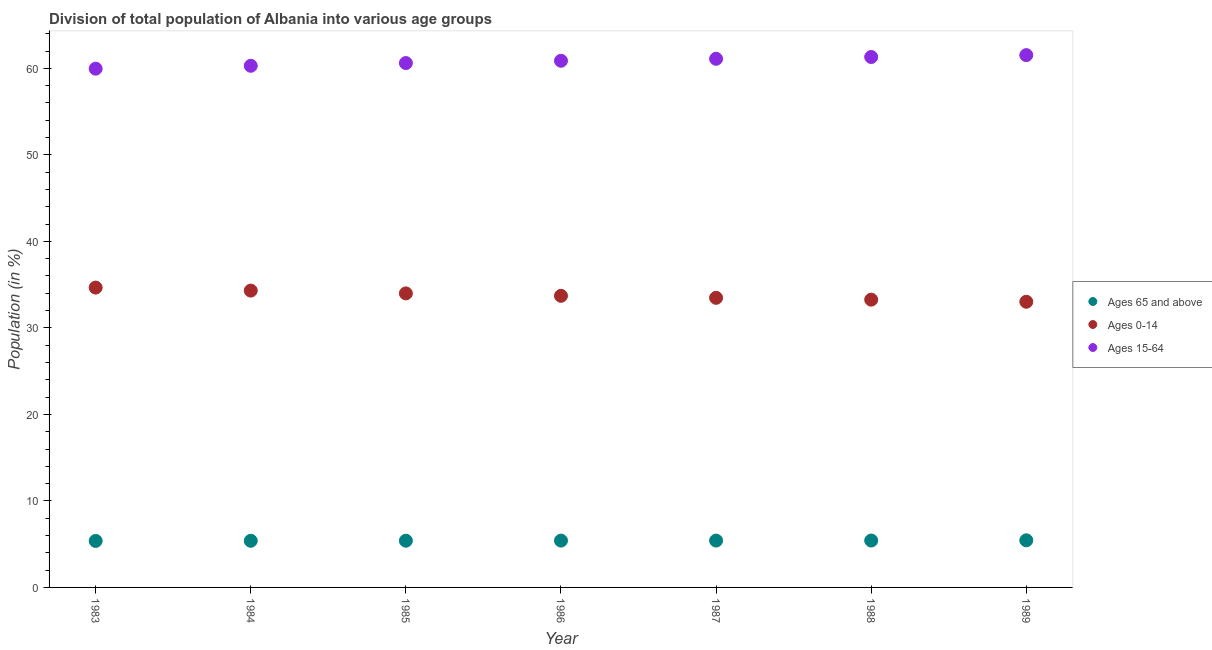How many different coloured dotlines are there?
Your answer should be very brief. 3. Is the number of dotlines equal to the number of legend labels?
Provide a succinct answer. Yes. What is the percentage of population within the age-group 0-14 in 1988?
Keep it short and to the point. 33.26. Across all years, what is the maximum percentage of population within the age-group 15-64?
Give a very brief answer. 61.53. Across all years, what is the minimum percentage of population within the age-group 15-64?
Offer a terse response. 59.96. What is the total percentage of population within the age-group of 65 and above in the graph?
Offer a terse response. 37.86. What is the difference between the percentage of population within the age-group of 65 and above in 1984 and that in 1985?
Your answer should be very brief. -0.01. What is the difference between the percentage of population within the age-group 0-14 in 1986 and the percentage of population within the age-group of 65 and above in 1984?
Give a very brief answer. 28.32. What is the average percentage of population within the age-group 0-14 per year?
Offer a very short reply. 33.78. In the year 1984, what is the difference between the percentage of population within the age-group 0-14 and percentage of population within the age-group of 65 and above?
Provide a succinct answer. 28.92. In how many years, is the percentage of population within the age-group of 65 and above greater than 22 %?
Your answer should be compact. 0. What is the ratio of the percentage of population within the age-group 15-64 in 1983 to that in 1984?
Offer a terse response. 0.99. Is the percentage of population within the age-group 0-14 in 1983 less than that in 1985?
Offer a terse response. No. Is the difference between the percentage of population within the age-group 15-64 in 1984 and 1987 greater than the difference between the percentage of population within the age-group 0-14 in 1984 and 1987?
Provide a short and direct response. No. What is the difference between the highest and the second highest percentage of population within the age-group 15-64?
Ensure brevity in your answer.  0.22. What is the difference between the highest and the lowest percentage of population within the age-group 15-64?
Ensure brevity in your answer.  1.57. In how many years, is the percentage of population within the age-group 0-14 greater than the average percentage of population within the age-group 0-14 taken over all years?
Your response must be concise. 3. Is the sum of the percentage of population within the age-group 15-64 in 1986 and 1988 greater than the maximum percentage of population within the age-group 0-14 across all years?
Your response must be concise. Yes. Is it the case that in every year, the sum of the percentage of population within the age-group of 65 and above and percentage of population within the age-group 0-14 is greater than the percentage of population within the age-group 15-64?
Your answer should be compact. No. Is the percentage of population within the age-group 0-14 strictly greater than the percentage of population within the age-group 15-64 over the years?
Give a very brief answer. No. How many years are there in the graph?
Provide a succinct answer. 7. Are the values on the major ticks of Y-axis written in scientific E-notation?
Your answer should be very brief. No. Where does the legend appear in the graph?
Your response must be concise. Center right. How many legend labels are there?
Offer a terse response. 3. How are the legend labels stacked?
Make the answer very short. Vertical. What is the title of the graph?
Offer a very short reply. Division of total population of Albania into various age groups
. Does "Natural Gas" appear as one of the legend labels in the graph?
Ensure brevity in your answer.  No. What is the label or title of the X-axis?
Keep it short and to the point. Year. What is the label or title of the Y-axis?
Your answer should be compact. Population (in %). What is the Population (in %) in Ages 65 and above in 1983?
Keep it short and to the point. 5.38. What is the Population (in %) of Ages 0-14 in 1983?
Make the answer very short. 34.66. What is the Population (in %) in Ages 15-64 in 1983?
Give a very brief answer. 59.96. What is the Population (in %) in Ages 65 and above in 1984?
Make the answer very short. 5.39. What is the Population (in %) in Ages 0-14 in 1984?
Ensure brevity in your answer.  34.31. What is the Population (in %) in Ages 15-64 in 1984?
Provide a short and direct response. 60.3. What is the Population (in %) of Ages 65 and above in 1985?
Provide a succinct answer. 5.4. What is the Population (in %) in Ages 0-14 in 1985?
Provide a short and direct response. 33.99. What is the Population (in %) of Ages 15-64 in 1985?
Provide a short and direct response. 60.61. What is the Population (in %) in Ages 65 and above in 1986?
Your answer should be compact. 5.41. What is the Population (in %) in Ages 0-14 in 1986?
Provide a short and direct response. 33.71. What is the Population (in %) in Ages 15-64 in 1986?
Your answer should be compact. 60.88. What is the Population (in %) in Ages 65 and above in 1987?
Provide a short and direct response. 5.42. What is the Population (in %) in Ages 0-14 in 1987?
Offer a terse response. 33.48. What is the Population (in %) of Ages 15-64 in 1987?
Keep it short and to the point. 61.11. What is the Population (in %) in Ages 65 and above in 1988?
Provide a short and direct response. 5.42. What is the Population (in %) of Ages 0-14 in 1988?
Keep it short and to the point. 33.26. What is the Population (in %) of Ages 15-64 in 1988?
Your answer should be compact. 61.31. What is the Population (in %) in Ages 65 and above in 1989?
Your answer should be very brief. 5.45. What is the Population (in %) in Ages 0-14 in 1989?
Keep it short and to the point. 33.02. What is the Population (in %) in Ages 15-64 in 1989?
Make the answer very short. 61.53. Across all years, what is the maximum Population (in %) in Ages 65 and above?
Make the answer very short. 5.45. Across all years, what is the maximum Population (in %) in Ages 0-14?
Provide a succinct answer. 34.66. Across all years, what is the maximum Population (in %) of Ages 15-64?
Your answer should be compact. 61.53. Across all years, what is the minimum Population (in %) of Ages 65 and above?
Keep it short and to the point. 5.38. Across all years, what is the minimum Population (in %) in Ages 0-14?
Make the answer very short. 33.02. Across all years, what is the minimum Population (in %) of Ages 15-64?
Provide a succinct answer. 59.96. What is the total Population (in %) of Ages 65 and above in the graph?
Your answer should be very brief. 37.86. What is the total Population (in %) of Ages 0-14 in the graph?
Make the answer very short. 236.43. What is the total Population (in %) of Ages 15-64 in the graph?
Your answer should be very brief. 425.71. What is the difference between the Population (in %) in Ages 65 and above in 1983 and that in 1984?
Offer a very short reply. -0.02. What is the difference between the Population (in %) in Ages 0-14 in 1983 and that in 1984?
Provide a short and direct response. 0.35. What is the difference between the Population (in %) of Ages 15-64 in 1983 and that in 1984?
Offer a terse response. -0.33. What is the difference between the Population (in %) of Ages 65 and above in 1983 and that in 1985?
Provide a succinct answer. -0.02. What is the difference between the Population (in %) of Ages 0-14 in 1983 and that in 1985?
Keep it short and to the point. 0.67. What is the difference between the Population (in %) in Ages 15-64 in 1983 and that in 1985?
Ensure brevity in your answer.  -0.65. What is the difference between the Population (in %) of Ages 65 and above in 1983 and that in 1986?
Your response must be concise. -0.04. What is the difference between the Population (in %) of Ages 0-14 in 1983 and that in 1986?
Provide a succinct answer. 0.95. What is the difference between the Population (in %) in Ages 15-64 in 1983 and that in 1986?
Offer a terse response. -0.91. What is the difference between the Population (in %) in Ages 65 and above in 1983 and that in 1987?
Make the answer very short. -0.04. What is the difference between the Population (in %) in Ages 0-14 in 1983 and that in 1987?
Give a very brief answer. 1.18. What is the difference between the Population (in %) of Ages 15-64 in 1983 and that in 1987?
Ensure brevity in your answer.  -1.14. What is the difference between the Population (in %) of Ages 65 and above in 1983 and that in 1988?
Provide a short and direct response. -0.04. What is the difference between the Population (in %) in Ages 0-14 in 1983 and that in 1988?
Give a very brief answer. 1.39. What is the difference between the Population (in %) of Ages 15-64 in 1983 and that in 1988?
Offer a very short reply. -1.35. What is the difference between the Population (in %) in Ages 65 and above in 1983 and that in 1989?
Your response must be concise. -0.07. What is the difference between the Population (in %) of Ages 0-14 in 1983 and that in 1989?
Make the answer very short. 1.64. What is the difference between the Population (in %) in Ages 15-64 in 1983 and that in 1989?
Give a very brief answer. -1.57. What is the difference between the Population (in %) in Ages 65 and above in 1984 and that in 1985?
Provide a succinct answer. -0.01. What is the difference between the Population (in %) in Ages 0-14 in 1984 and that in 1985?
Your response must be concise. 0.32. What is the difference between the Population (in %) of Ages 15-64 in 1984 and that in 1985?
Offer a terse response. -0.31. What is the difference between the Population (in %) in Ages 65 and above in 1984 and that in 1986?
Offer a terse response. -0.02. What is the difference between the Population (in %) of Ages 0-14 in 1984 and that in 1986?
Offer a terse response. 0.6. What is the difference between the Population (in %) of Ages 15-64 in 1984 and that in 1986?
Make the answer very short. -0.58. What is the difference between the Population (in %) of Ages 65 and above in 1984 and that in 1987?
Offer a very short reply. -0.02. What is the difference between the Population (in %) in Ages 0-14 in 1984 and that in 1987?
Provide a short and direct response. 0.83. What is the difference between the Population (in %) in Ages 15-64 in 1984 and that in 1987?
Ensure brevity in your answer.  -0.81. What is the difference between the Population (in %) in Ages 65 and above in 1984 and that in 1988?
Your answer should be very brief. -0.03. What is the difference between the Population (in %) in Ages 0-14 in 1984 and that in 1988?
Give a very brief answer. 1.05. What is the difference between the Population (in %) in Ages 15-64 in 1984 and that in 1988?
Provide a short and direct response. -1.02. What is the difference between the Population (in %) in Ages 65 and above in 1984 and that in 1989?
Provide a short and direct response. -0.05. What is the difference between the Population (in %) in Ages 0-14 in 1984 and that in 1989?
Provide a succinct answer. 1.29. What is the difference between the Population (in %) of Ages 15-64 in 1984 and that in 1989?
Your answer should be compact. -1.23. What is the difference between the Population (in %) in Ages 65 and above in 1985 and that in 1986?
Keep it short and to the point. -0.01. What is the difference between the Population (in %) in Ages 0-14 in 1985 and that in 1986?
Your answer should be compact. 0.28. What is the difference between the Population (in %) of Ages 15-64 in 1985 and that in 1986?
Your response must be concise. -0.26. What is the difference between the Population (in %) of Ages 65 and above in 1985 and that in 1987?
Make the answer very short. -0.02. What is the difference between the Population (in %) in Ages 0-14 in 1985 and that in 1987?
Your answer should be compact. 0.51. What is the difference between the Population (in %) of Ages 15-64 in 1985 and that in 1987?
Your response must be concise. -0.49. What is the difference between the Population (in %) in Ages 65 and above in 1985 and that in 1988?
Offer a very short reply. -0.02. What is the difference between the Population (in %) in Ages 0-14 in 1985 and that in 1988?
Keep it short and to the point. 0.72. What is the difference between the Population (in %) in Ages 15-64 in 1985 and that in 1988?
Offer a very short reply. -0.7. What is the difference between the Population (in %) in Ages 65 and above in 1985 and that in 1989?
Offer a very short reply. -0.05. What is the difference between the Population (in %) of Ages 0-14 in 1985 and that in 1989?
Keep it short and to the point. 0.97. What is the difference between the Population (in %) in Ages 15-64 in 1985 and that in 1989?
Give a very brief answer. -0.92. What is the difference between the Population (in %) of Ages 65 and above in 1986 and that in 1987?
Offer a terse response. -0. What is the difference between the Population (in %) of Ages 0-14 in 1986 and that in 1987?
Your answer should be compact. 0.23. What is the difference between the Population (in %) of Ages 15-64 in 1986 and that in 1987?
Provide a short and direct response. -0.23. What is the difference between the Population (in %) of Ages 65 and above in 1986 and that in 1988?
Your answer should be very brief. -0.01. What is the difference between the Population (in %) in Ages 0-14 in 1986 and that in 1988?
Make the answer very short. 0.45. What is the difference between the Population (in %) in Ages 15-64 in 1986 and that in 1988?
Keep it short and to the point. -0.44. What is the difference between the Population (in %) of Ages 65 and above in 1986 and that in 1989?
Your answer should be compact. -0.03. What is the difference between the Population (in %) in Ages 0-14 in 1986 and that in 1989?
Offer a very short reply. 0.69. What is the difference between the Population (in %) in Ages 15-64 in 1986 and that in 1989?
Provide a succinct answer. -0.65. What is the difference between the Population (in %) of Ages 65 and above in 1987 and that in 1988?
Make the answer very short. -0. What is the difference between the Population (in %) in Ages 0-14 in 1987 and that in 1988?
Offer a terse response. 0.21. What is the difference between the Population (in %) of Ages 15-64 in 1987 and that in 1988?
Provide a succinct answer. -0.21. What is the difference between the Population (in %) in Ages 65 and above in 1987 and that in 1989?
Give a very brief answer. -0.03. What is the difference between the Population (in %) of Ages 0-14 in 1987 and that in 1989?
Provide a succinct answer. 0.45. What is the difference between the Population (in %) in Ages 15-64 in 1987 and that in 1989?
Give a very brief answer. -0.42. What is the difference between the Population (in %) in Ages 65 and above in 1988 and that in 1989?
Make the answer very short. -0.03. What is the difference between the Population (in %) in Ages 0-14 in 1988 and that in 1989?
Offer a terse response. 0.24. What is the difference between the Population (in %) in Ages 15-64 in 1988 and that in 1989?
Your response must be concise. -0.22. What is the difference between the Population (in %) of Ages 65 and above in 1983 and the Population (in %) of Ages 0-14 in 1984?
Your response must be concise. -28.94. What is the difference between the Population (in %) of Ages 65 and above in 1983 and the Population (in %) of Ages 15-64 in 1984?
Your answer should be very brief. -54.92. What is the difference between the Population (in %) in Ages 0-14 in 1983 and the Population (in %) in Ages 15-64 in 1984?
Provide a succinct answer. -25.64. What is the difference between the Population (in %) of Ages 65 and above in 1983 and the Population (in %) of Ages 0-14 in 1985?
Your response must be concise. -28.61. What is the difference between the Population (in %) in Ages 65 and above in 1983 and the Population (in %) in Ages 15-64 in 1985?
Your answer should be very brief. -55.24. What is the difference between the Population (in %) in Ages 0-14 in 1983 and the Population (in %) in Ages 15-64 in 1985?
Offer a very short reply. -25.95. What is the difference between the Population (in %) in Ages 65 and above in 1983 and the Population (in %) in Ages 0-14 in 1986?
Your response must be concise. -28.33. What is the difference between the Population (in %) of Ages 65 and above in 1983 and the Population (in %) of Ages 15-64 in 1986?
Provide a short and direct response. -55.5. What is the difference between the Population (in %) of Ages 0-14 in 1983 and the Population (in %) of Ages 15-64 in 1986?
Keep it short and to the point. -26.22. What is the difference between the Population (in %) of Ages 65 and above in 1983 and the Population (in %) of Ages 0-14 in 1987?
Keep it short and to the point. -28.1. What is the difference between the Population (in %) in Ages 65 and above in 1983 and the Population (in %) in Ages 15-64 in 1987?
Your answer should be very brief. -55.73. What is the difference between the Population (in %) in Ages 0-14 in 1983 and the Population (in %) in Ages 15-64 in 1987?
Provide a short and direct response. -26.45. What is the difference between the Population (in %) in Ages 65 and above in 1983 and the Population (in %) in Ages 0-14 in 1988?
Your answer should be compact. -27.89. What is the difference between the Population (in %) of Ages 65 and above in 1983 and the Population (in %) of Ages 15-64 in 1988?
Your answer should be compact. -55.94. What is the difference between the Population (in %) in Ages 0-14 in 1983 and the Population (in %) in Ages 15-64 in 1988?
Provide a succinct answer. -26.66. What is the difference between the Population (in %) in Ages 65 and above in 1983 and the Population (in %) in Ages 0-14 in 1989?
Offer a very short reply. -27.65. What is the difference between the Population (in %) in Ages 65 and above in 1983 and the Population (in %) in Ages 15-64 in 1989?
Provide a succinct answer. -56.16. What is the difference between the Population (in %) in Ages 0-14 in 1983 and the Population (in %) in Ages 15-64 in 1989?
Give a very brief answer. -26.87. What is the difference between the Population (in %) of Ages 65 and above in 1984 and the Population (in %) of Ages 0-14 in 1985?
Provide a short and direct response. -28.6. What is the difference between the Population (in %) of Ages 65 and above in 1984 and the Population (in %) of Ages 15-64 in 1985?
Give a very brief answer. -55.22. What is the difference between the Population (in %) in Ages 0-14 in 1984 and the Population (in %) in Ages 15-64 in 1985?
Ensure brevity in your answer.  -26.3. What is the difference between the Population (in %) of Ages 65 and above in 1984 and the Population (in %) of Ages 0-14 in 1986?
Your answer should be very brief. -28.32. What is the difference between the Population (in %) in Ages 65 and above in 1984 and the Population (in %) in Ages 15-64 in 1986?
Provide a short and direct response. -55.49. What is the difference between the Population (in %) in Ages 0-14 in 1984 and the Population (in %) in Ages 15-64 in 1986?
Provide a succinct answer. -26.57. What is the difference between the Population (in %) in Ages 65 and above in 1984 and the Population (in %) in Ages 0-14 in 1987?
Keep it short and to the point. -28.09. What is the difference between the Population (in %) in Ages 65 and above in 1984 and the Population (in %) in Ages 15-64 in 1987?
Your answer should be very brief. -55.72. What is the difference between the Population (in %) in Ages 0-14 in 1984 and the Population (in %) in Ages 15-64 in 1987?
Your response must be concise. -26.8. What is the difference between the Population (in %) in Ages 65 and above in 1984 and the Population (in %) in Ages 0-14 in 1988?
Give a very brief answer. -27.87. What is the difference between the Population (in %) of Ages 65 and above in 1984 and the Population (in %) of Ages 15-64 in 1988?
Provide a succinct answer. -55.92. What is the difference between the Population (in %) of Ages 0-14 in 1984 and the Population (in %) of Ages 15-64 in 1988?
Your answer should be very brief. -27. What is the difference between the Population (in %) of Ages 65 and above in 1984 and the Population (in %) of Ages 0-14 in 1989?
Provide a succinct answer. -27.63. What is the difference between the Population (in %) in Ages 65 and above in 1984 and the Population (in %) in Ages 15-64 in 1989?
Keep it short and to the point. -56.14. What is the difference between the Population (in %) in Ages 0-14 in 1984 and the Population (in %) in Ages 15-64 in 1989?
Offer a terse response. -27.22. What is the difference between the Population (in %) in Ages 65 and above in 1985 and the Population (in %) in Ages 0-14 in 1986?
Your answer should be very brief. -28.31. What is the difference between the Population (in %) in Ages 65 and above in 1985 and the Population (in %) in Ages 15-64 in 1986?
Make the answer very short. -55.48. What is the difference between the Population (in %) in Ages 0-14 in 1985 and the Population (in %) in Ages 15-64 in 1986?
Your response must be concise. -26.89. What is the difference between the Population (in %) in Ages 65 and above in 1985 and the Population (in %) in Ages 0-14 in 1987?
Provide a short and direct response. -28.08. What is the difference between the Population (in %) of Ages 65 and above in 1985 and the Population (in %) of Ages 15-64 in 1987?
Offer a terse response. -55.71. What is the difference between the Population (in %) of Ages 0-14 in 1985 and the Population (in %) of Ages 15-64 in 1987?
Provide a short and direct response. -27.12. What is the difference between the Population (in %) in Ages 65 and above in 1985 and the Population (in %) in Ages 0-14 in 1988?
Keep it short and to the point. -27.86. What is the difference between the Population (in %) of Ages 65 and above in 1985 and the Population (in %) of Ages 15-64 in 1988?
Offer a very short reply. -55.91. What is the difference between the Population (in %) in Ages 0-14 in 1985 and the Population (in %) in Ages 15-64 in 1988?
Provide a short and direct response. -27.33. What is the difference between the Population (in %) in Ages 65 and above in 1985 and the Population (in %) in Ages 0-14 in 1989?
Your response must be concise. -27.62. What is the difference between the Population (in %) in Ages 65 and above in 1985 and the Population (in %) in Ages 15-64 in 1989?
Your answer should be compact. -56.13. What is the difference between the Population (in %) in Ages 0-14 in 1985 and the Population (in %) in Ages 15-64 in 1989?
Provide a short and direct response. -27.54. What is the difference between the Population (in %) in Ages 65 and above in 1986 and the Population (in %) in Ages 0-14 in 1987?
Your answer should be compact. -28.06. What is the difference between the Population (in %) in Ages 65 and above in 1986 and the Population (in %) in Ages 15-64 in 1987?
Provide a short and direct response. -55.69. What is the difference between the Population (in %) of Ages 0-14 in 1986 and the Population (in %) of Ages 15-64 in 1987?
Offer a very short reply. -27.4. What is the difference between the Population (in %) in Ages 65 and above in 1986 and the Population (in %) in Ages 0-14 in 1988?
Give a very brief answer. -27.85. What is the difference between the Population (in %) of Ages 65 and above in 1986 and the Population (in %) of Ages 15-64 in 1988?
Offer a terse response. -55.9. What is the difference between the Population (in %) of Ages 0-14 in 1986 and the Population (in %) of Ages 15-64 in 1988?
Provide a succinct answer. -27.6. What is the difference between the Population (in %) in Ages 65 and above in 1986 and the Population (in %) in Ages 0-14 in 1989?
Keep it short and to the point. -27.61. What is the difference between the Population (in %) of Ages 65 and above in 1986 and the Population (in %) of Ages 15-64 in 1989?
Your answer should be very brief. -56.12. What is the difference between the Population (in %) of Ages 0-14 in 1986 and the Population (in %) of Ages 15-64 in 1989?
Your answer should be very brief. -27.82. What is the difference between the Population (in %) in Ages 65 and above in 1987 and the Population (in %) in Ages 0-14 in 1988?
Offer a terse response. -27.85. What is the difference between the Population (in %) in Ages 65 and above in 1987 and the Population (in %) in Ages 15-64 in 1988?
Provide a short and direct response. -55.9. What is the difference between the Population (in %) in Ages 0-14 in 1987 and the Population (in %) in Ages 15-64 in 1988?
Ensure brevity in your answer.  -27.84. What is the difference between the Population (in %) of Ages 65 and above in 1987 and the Population (in %) of Ages 0-14 in 1989?
Offer a very short reply. -27.61. What is the difference between the Population (in %) of Ages 65 and above in 1987 and the Population (in %) of Ages 15-64 in 1989?
Your answer should be compact. -56.12. What is the difference between the Population (in %) of Ages 0-14 in 1987 and the Population (in %) of Ages 15-64 in 1989?
Make the answer very short. -28.06. What is the difference between the Population (in %) in Ages 65 and above in 1988 and the Population (in %) in Ages 0-14 in 1989?
Provide a short and direct response. -27.6. What is the difference between the Population (in %) in Ages 65 and above in 1988 and the Population (in %) in Ages 15-64 in 1989?
Keep it short and to the point. -56.11. What is the difference between the Population (in %) in Ages 0-14 in 1988 and the Population (in %) in Ages 15-64 in 1989?
Keep it short and to the point. -28.27. What is the average Population (in %) of Ages 65 and above per year?
Offer a very short reply. 5.41. What is the average Population (in %) of Ages 0-14 per year?
Make the answer very short. 33.78. What is the average Population (in %) in Ages 15-64 per year?
Provide a succinct answer. 60.82. In the year 1983, what is the difference between the Population (in %) of Ages 65 and above and Population (in %) of Ages 0-14?
Your answer should be very brief. -29.28. In the year 1983, what is the difference between the Population (in %) in Ages 65 and above and Population (in %) in Ages 15-64?
Your response must be concise. -54.59. In the year 1983, what is the difference between the Population (in %) in Ages 0-14 and Population (in %) in Ages 15-64?
Keep it short and to the point. -25.3. In the year 1984, what is the difference between the Population (in %) of Ages 65 and above and Population (in %) of Ages 0-14?
Provide a succinct answer. -28.92. In the year 1984, what is the difference between the Population (in %) in Ages 65 and above and Population (in %) in Ages 15-64?
Your answer should be very brief. -54.91. In the year 1984, what is the difference between the Population (in %) in Ages 0-14 and Population (in %) in Ages 15-64?
Make the answer very short. -25.99. In the year 1985, what is the difference between the Population (in %) of Ages 65 and above and Population (in %) of Ages 0-14?
Offer a very short reply. -28.59. In the year 1985, what is the difference between the Population (in %) in Ages 65 and above and Population (in %) in Ages 15-64?
Ensure brevity in your answer.  -55.21. In the year 1985, what is the difference between the Population (in %) of Ages 0-14 and Population (in %) of Ages 15-64?
Provide a succinct answer. -26.63. In the year 1986, what is the difference between the Population (in %) in Ages 65 and above and Population (in %) in Ages 0-14?
Give a very brief answer. -28.3. In the year 1986, what is the difference between the Population (in %) in Ages 65 and above and Population (in %) in Ages 15-64?
Provide a succinct answer. -55.46. In the year 1986, what is the difference between the Population (in %) of Ages 0-14 and Population (in %) of Ages 15-64?
Give a very brief answer. -27.17. In the year 1987, what is the difference between the Population (in %) in Ages 65 and above and Population (in %) in Ages 0-14?
Offer a terse response. -28.06. In the year 1987, what is the difference between the Population (in %) in Ages 65 and above and Population (in %) in Ages 15-64?
Provide a succinct answer. -55.69. In the year 1987, what is the difference between the Population (in %) of Ages 0-14 and Population (in %) of Ages 15-64?
Provide a short and direct response. -27.63. In the year 1988, what is the difference between the Population (in %) in Ages 65 and above and Population (in %) in Ages 0-14?
Offer a terse response. -27.84. In the year 1988, what is the difference between the Population (in %) in Ages 65 and above and Population (in %) in Ages 15-64?
Give a very brief answer. -55.89. In the year 1988, what is the difference between the Population (in %) of Ages 0-14 and Population (in %) of Ages 15-64?
Give a very brief answer. -28.05. In the year 1989, what is the difference between the Population (in %) of Ages 65 and above and Population (in %) of Ages 0-14?
Your answer should be very brief. -27.58. In the year 1989, what is the difference between the Population (in %) of Ages 65 and above and Population (in %) of Ages 15-64?
Your answer should be compact. -56.09. In the year 1989, what is the difference between the Population (in %) of Ages 0-14 and Population (in %) of Ages 15-64?
Your answer should be compact. -28.51. What is the ratio of the Population (in %) in Ages 65 and above in 1983 to that in 1984?
Ensure brevity in your answer.  1. What is the ratio of the Population (in %) of Ages 0-14 in 1983 to that in 1984?
Your answer should be compact. 1.01. What is the ratio of the Population (in %) in Ages 15-64 in 1983 to that in 1984?
Keep it short and to the point. 0.99. What is the ratio of the Population (in %) of Ages 65 and above in 1983 to that in 1985?
Your answer should be compact. 1. What is the ratio of the Population (in %) in Ages 0-14 in 1983 to that in 1985?
Ensure brevity in your answer.  1.02. What is the ratio of the Population (in %) in Ages 15-64 in 1983 to that in 1985?
Offer a very short reply. 0.99. What is the ratio of the Population (in %) of Ages 0-14 in 1983 to that in 1986?
Provide a short and direct response. 1.03. What is the ratio of the Population (in %) of Ages 65 and above in 1983 to that in 1987?
Ensure brevity in your answer.  0.99. What is the ratio of the Population (in %) of Ages 0-14 in 1983 to that in 1987?
Ensure brevity in your answer.  1.04. What is the ratio of the Population (in %) of Ages 15-64 in 1983 to that in 1987?
Give a very brief answer. 0.98. What is the ratio of the Population (in %) in Ages 0-14 in 1983 to that in 1988?
Give a very brief answer. 1.04. What is the ratio of the Population (in %) in Ages 65 and above in 1983 to that in 1989?
Your answer should be compact. 0.99. What is the ratio of the Population (in %) of Ages 0-14 in 1983 to that in 1989?
Offer a terse response. 1.05. What is the ratio of the Population (in %) in Ages 15-64 in 1983 to that in 1989?
Make the answer very short. 0.97. What is the ratio of the Population (in %) of Ages 0-14 in 1984 to that in 1985?
Your response must be concise. 1.01. What is the ratio of the Population (in %) of Ages 0-14 in 1984 to that in 1986?
Your answer should be compact. 1.02. What is the ratio of the Population (in %) of Ages 65 and above in 1984 to that in 1987?
Provide a short and direct response. 1. What is the ratio of the Population (in %) of Ages 0-14 in 1984 to that in 1987?
Make the answer very short. 1.02. What is the ratio of the Population (in %) of Ages 65 and above in 1984 to that in 1988?
Your response must be concise. 0.99. What is the ratio of the Population (in %) of Ages 0-14 in 1984 to that in 1988?
Give a very brief answer. 1.03. What is the ratio of the Population (in %) of Ages 15-64 in 1984 to that in 1988?
Your answer should be very brief. 0.98. What is the ratio of the Population (in %) of Ages 0-14 in 1984 to that in 1989?
Your answer should be compact. 1.04. What is the ratio of the Population (in %) in Ages 15-64 in 1984 to that in 1989?
Keep it short and to the point. 0.98. What is the ratio of the Population (in %) of Ages 65 and above in 1985 to that in 1986?
Your answer should be very brief. 1. What is the ratio of the Population (in %) in Ages 0-14 in 1985 to that in 1986?
Offer a very short reply. 1.01. What is the ratio of the Population (in %) of Ages 15-64 in 1985 to that in 1986?
Offer a terse response. 1. What is the ratio of the Population (in %) in Ages 65 and above in 1985 to that in 1987?
Give a very brief answer. 1. What is the ratio of the Population (in %) in Ages 0-14 in 1985 to that in 1987?
Offer a terse response. 1.02. What is the ratio of the Population (in %) in Ages 0-14 in 1985 to that in 1988?
Ensure brevity in your answer.  1.02. What is the ratio of the Population (in %) of Ages 65 and above in 1985 to that in 1989?
Your answer should be compact. 0.99. What is the ratio of the Population (in %) in Ages 0-14 in 1985 to that in 1989?
Make the answer very short. 1.03. What is the ratio of the Population (in %) in Ages 15-64 in 1985 to that in 1989?
Offer a very short reply. 0.99. What is the ratio of the Population (in %) of Ages 0-14 in 1986 to that in 1987?
Ensure brevity in your answer.  1.01. What is the ratio of the Population (in %) of Ages 0-14 in 1986 to that in 1988?
Your answer should be very brief. 1.01. What is the ratio of the Population (in %) in Ages 0-14 in 1986 to that in 1989?
Your answer should be compact. 1.02. What is the ratio of the Population (in %) in Ages 15-64 in 1986 to that in 1989?
Offer a terse response. 0.99. What is the ratio of the Population (in %) in Ages 65 and above in 1987 to that in 1988?
Your response must be concise. 1. What is the ratio of the Population (in %) of Ages 0-14 in 1987 to that in 1988?
Offer a very short reply. 1.01. What is the ratio of the Population (in %) in Ages 15-64 in 1987 to that in 1988?
Your response must be concise. 1. What is the ratio of the Population (in %) in Ages 65 and above in 1987 to that in 1989?
Your answer should be very brief. 0.99. What is the ratio of the Population (in %) of Ages 0-14 in 1987 to that in 1989?
Your answer should be very brief. 1.01. What is the ratio of the Population (in %) of Ages 65 and above in 1988 to that in 1989?
Give a very brief answer. 1. What is the ratio of the Population (in %) in Ages 0-14 in 1988 to that in 1989?
Give a very brief answer. 1.01. What is the difference between the highest and the second highest Population (in %) in Ages 65 and above?
Your response must be concise. 0.03. What is the difference between the highest and the second highest Population (in %) in Ages 0-14?
Offer a terse response. 0.35. What is the difference between the highest and the second highest Population (in %) in Ages 15-64?
Your response must be concise. 0.22. What is the difference between the highest and the lowest Population (in %) of Ages 65 and above?
Your answer should be compact. 0.07. What is the difference between the highest and the lowest Population (in %) of Ages 0-14?
Make the answer very short. 1.64. What is the difference between the highest and the lowest Population (in %) of Ages 15-64?
Your answer should be very brief. 1.57. 